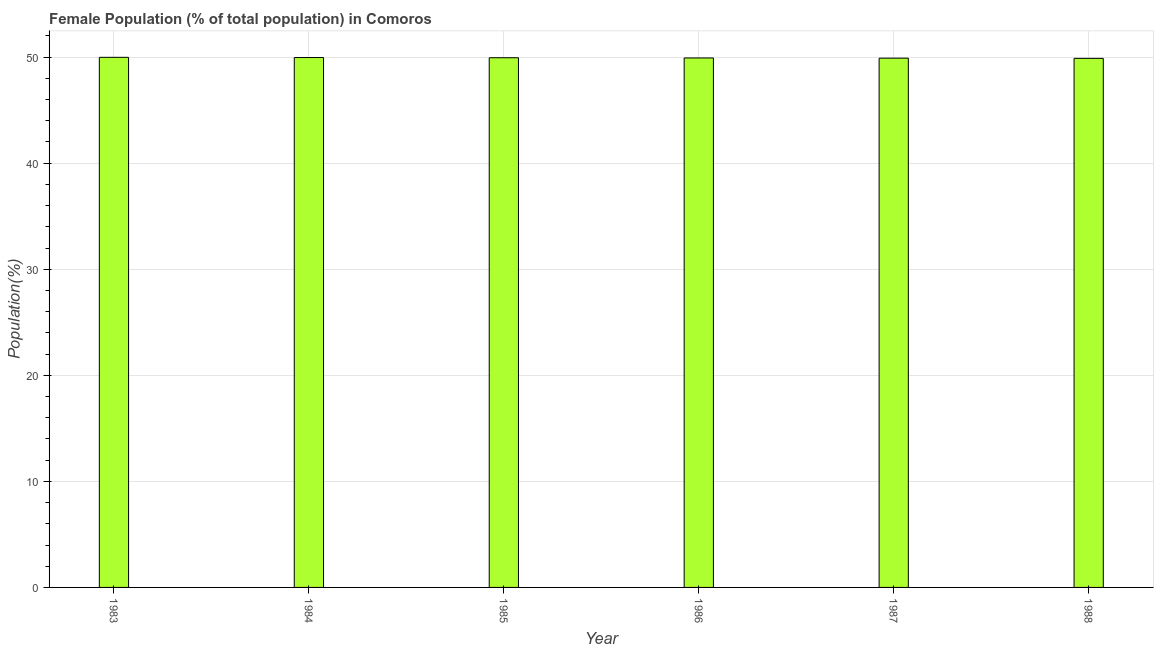What is the title of the graph?
Keep it short and to the point. Female Population (% of total population) in Comoros. What is the label or title of the X-axis?
Your answer should be very brief. Year. What is the label or title of the Y-axis?
Your answer should be compact. Population(%). What is the female population in 1988?
Give a very brief answer. 49.88. Across all years, what is the maximum female population?
Give a very brief answer. 49.98. Across all years, what is the minimum female population?
Keep it short and to the point. 49.88. In which year was the female population minimum?
Offer a very short reply. 1988. What is the sum of the female population?
Provide a succinct answer. 299.6. What is the average female population per year?
Make the answer very short. 49.93. What is the median female population?
Keep it short and to the point. 49.93. In how many years, is the female population greater than 4 %?
Offer a very short reply. 6. Is the female population in 1983 less than that in 1985?
Offer a terse response. No. What is the difference between the highest and the second highest female population?
Provide a succinct answer. 0.02. Is the sum of the female population in 1984 and 1987 greater than the maximum female population across all years?
Provide a succinct answer. Yes. In how many years, is the female population greater than the average female population taken over all years?
Offer a terse response. 3. How many years are there in the graph?
Your answer should be very brief. 6. What is the difference between two consecutive major ticks on the Y-axis?
Your answer should be very brief. 10. What is the Population(%) of 1983?
Ensure brevity in your answer.  49.98. What is the Population(%) in 1984?
Offer a very short reply. 49.96. What is the Population(%) in 1985?
Keep it short and to the point. 49.94. What is the Population(%) in 1986?
Offer a very short reply. 49.92. What is the Population(%) of 1987?
Make the answer very short. 49.9. What is the Population(%) in 1988?
Make the answer very short. 49.88. What is the difference between the Population(%) in 1983 and 1984?
Ensure brevity in your answer.  0.02. What is the difference between the Population(%) in 1983 and 1985?
Make the answer very short. 0.04. What is the difference between the Population(%) in 1983 and 1986?
Keep it short and to the point. 0.06. What is the difference between the Population(%) in 1983 and 1987?
Give a very brief answer. 0.08. What is the difference between the Population(%) in 1983 and 1988?
Your answer should be compact. 0.1. What is the difference between the Population(%) in 1984 and 1985?
Keep it short and to the point. 0.02. What is the difference between the Population(%) in 1984 and 1986?
Your answer should be compact. 0.04. What is the difference between the Population(%) in 1984 and 1987?
Your answer should be very brief. 0.06. What is the difference between the Population(%) in 1984 and 1988?
Keep it short and to the point. 0.08. What is the difference between the Population(%) in 1985 and 1986?
Ensure brevity in your answer.  0.02. What is the difference between the Population(%) in 1985 and 1987?
Offer a terse response. 0.04. What is the difference between the Population(%) in 1985 and 1988?
Offer a very short reply. 0.06. What is the difference between the Population(%) in 1986 and 1987?
Offer a very short reply. 0.02. What is the difference between the Population(%) in 1986 and 1988?
Keep it short and to the point. 0.04. What is the difference between the Population(%) in 1987 and 1988?
Provide a short and direct response. 0.02. What is the ratio of the Population(%) in 1983 to that in 1984?
Your answer should be compact. 1. What is the ratio of the Population(%) in 1983 to that in 1988?
Offer a very short reply. 1. What is the ratio of the Population(%) in 1984 to that in 1985?
Make the answer very short. 1. What is the ratio of the Population(%) in 1984 to that in 1986?
Offer a terse response. 1. What is the ratio of the Population(%) in 1984 to that in 1987?
Provide a short and direct response. 1. What is the ratio of the Population(%) in 1985 to that in 1986?
Your response must be concise. 1. What is the ratio of the Population(%) in 1985 to that in 1988?
Give a very brief answer. 1. What is the ratio of the Population(%) in 1987 to that in 1988?
Provide a short and direct response. 1. 